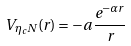Convert formula to latex. <formula><loc_0><loc_0><loc_500><loc_500>V _ { \eta _ { c } N } ( r ) = - a \, \frac { e ^ { - \alpha r } } { r } \,</formula> 